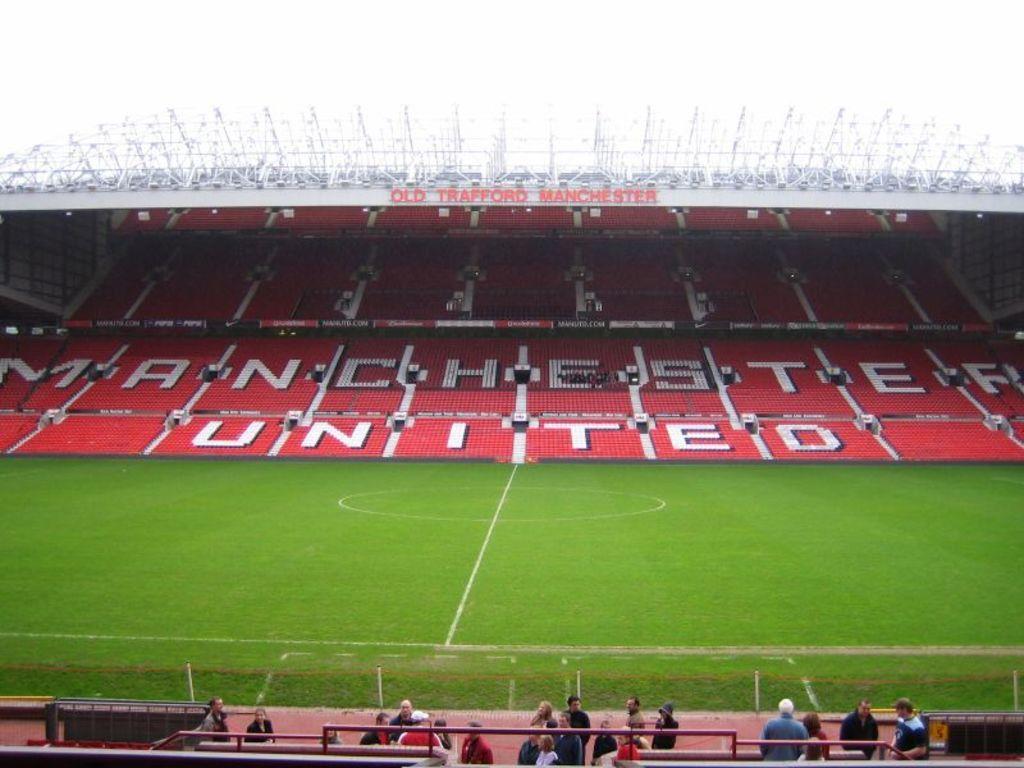How would you summarize this image in a sentence or two? This is the ground at the down side there are people standing, these are the sitting chairs in red color. 